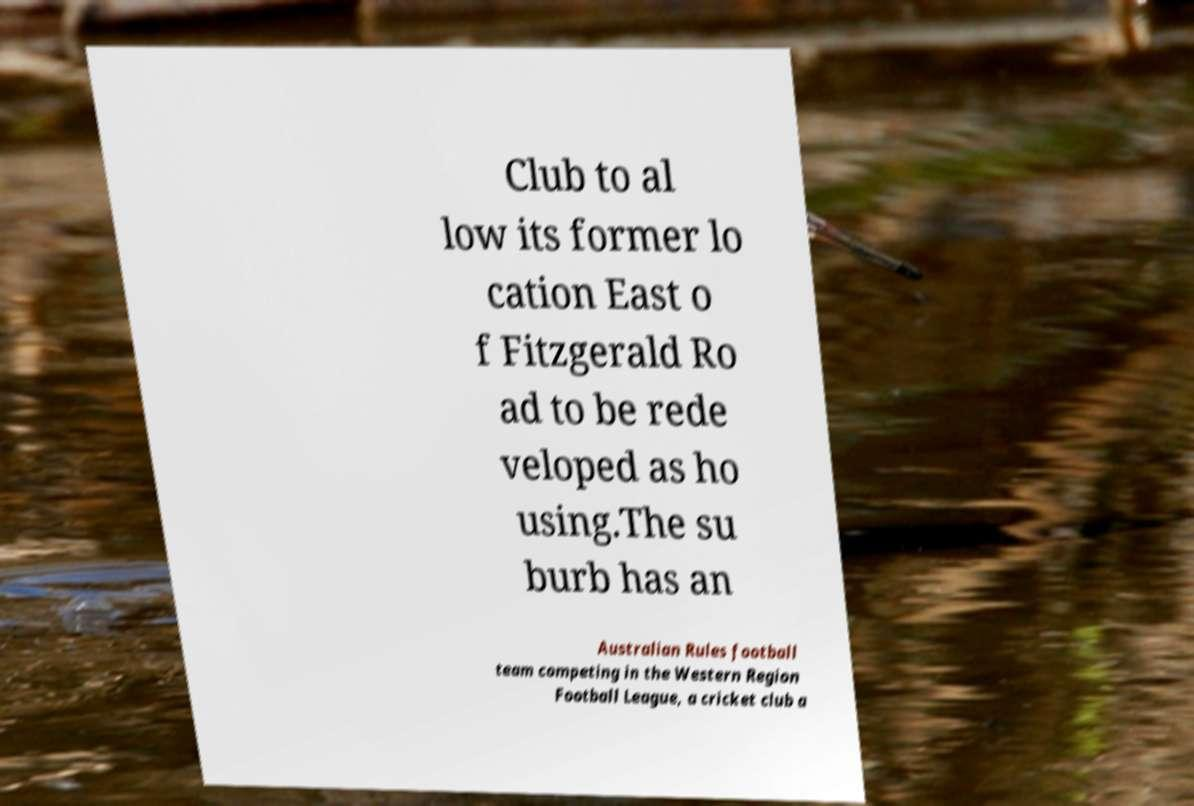Can you accurately transcribe the text from the provided image for me? Club to al low its former lo cation East o f Fitzgerald Ro ad to be rede veloped as ho using.The su burb has an Australian Rules football team competing in the Western Region Football League, a cricket club a 